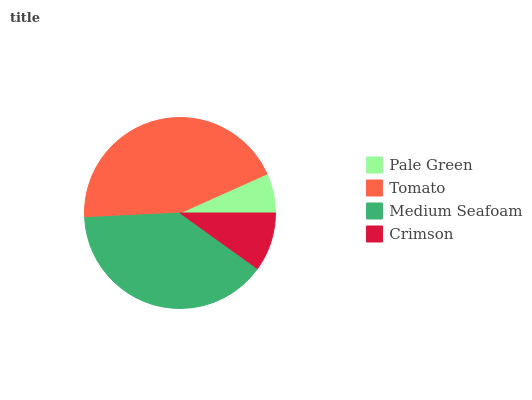Is Pale Green the minimum?
Answer yes or no. Yes. Is Tomato the maximum?
Answer yes or no. Yes. Is Medium Seafoam the minimum?
Answer yes or no. No. Is Medium Seafoam the maximum?
Answer yes or no. No. Is Tomato greater than Medium Seafoam?
Answer yes or no. Yes. Is Medium Seafoam less than Tomato?
Answer yes or no. Yes. Is Medium Seafoam greater than Tomato?
Answer yes or no. No. Is Tomato less than Medium Seafoam?
Answer yes or no. No. Is Medium Seafoam the high median?
Answer yes or no. Yes. Is Crimson the low median?
Answer yes or no. Yes. Is Pale Green the high median?
Answer yes or no. No. Is Pale Green the low median?
Answer yes or no. No. 